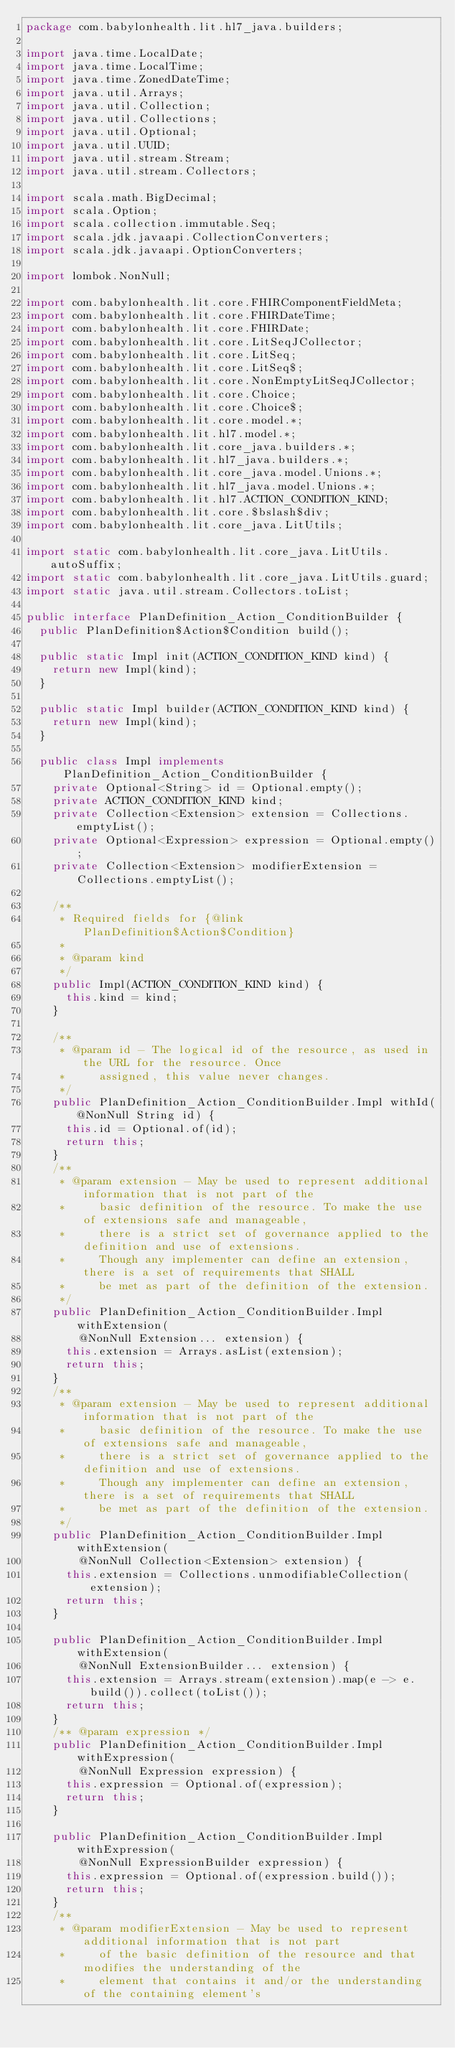<code> <loc_0><loc_0><loc_500><loc_500><_Java_>package com.babylonhealth.lit.hl7_java.builders;

import java.time.LocalDate;
import java.time.LocalTime;
import java.time.ZonedDateTime;
import java.util.Arrays;
import java.util.Collection;
import java.util.Collections;
import java.util.Optional;
import java.util.UUID;
import java.util.stream.Stream;
import java.util.stream.Collectors;

import scala.math.BigDecimal;
import scala.Option;
import scala.collection.immutable.Seq;
import scala.jdk.javaapi.CollectionConverters;
import scala.jdk.javaapi.OptionConverters;

import lombok.NonNull;

import com.babylonhealth.lit.core.FHIRComponentFieldMeta;
import com.babylonhealth.lit.core.FHIRDateTime;
import com.babylonhealth.lit.core.FHIRDate;
import com.babylonhealth.lit.core.LitSeqJCollector;
import com.babylonhealth.lit.core.LitSeq;
import com.babylonhealth.lit.core.LitSeq$;
import com.babylonhealth.lit.core.NonEmptyLitSeqJCollector;
import com.babylonhealth.lit.core.Choice;
import com.babylonhealth.lit.core.Choice$;
import com.babylonhealth.lit.core.model.*;
import com.babylonhealth.lit.hl7.model.*;
import com.babylonhealth.lit.core_java.builders.*;
import com.babylonhealth.lit.hl7_java.builders.*;
import com.babylonhealth.lit.core_java.model.Unions.*;
import com.babylonhealth.lit.hl7_java.model.Unions.*;
import com.babylonhealth.lit.hl7.ACTION_CONDITION_KIND;
import com.babylonhealth.lit.core.$bslash$div;
import com.babylonhealth.lit.core_java.LitUtils;

import static com.babylonhealth.lit.core_java.LitUtils.autoSuffix;
import static com.babylonhealth.lit.core_java.LitUtils.guard;
import static java.util.stream.Collectors.toList;

public interface PlanDefinition_Action_ConditionBuilder {
  public PlanDefinition$Action$Condition build();

  public static Impl init(ACTION_CONDITION_KIND kind) {
    return new Impl(kind);
  }

  public static Impl builder(ACTION_CONDITION_KIND kind) {
    return new Impl(kind);
  }

  public class Impl implements PlanDefinition_Action_ConditionBuilder {
    private Optional<String> id = Optional.empty();
    private ACTION_CONDITION_KIND kind;
    private Collection<Extension> extension = Collections.emptyList();
    private Optional<Expression> expression = Optional.empty();
    private Collection<Extension> modifierExtension = Collections.emptyList();

    /**
     * Required fields for {@link PlanDefinition$Action$Condition}
     *
     * @param kind
     */
    public Impl(ACTION_CONDITION_KIND kind) {
      this.kind = kind;
    }

    /**
     * @param id - The logical id of the resource, as used in the URL for the resource. Once
     *     assigned, this value never changes.
     */
    public PlanDefinition_Action_ConditionBuilder.Impl withId(@NonNull String id) {
      this.id = Optional.of(id);
      return this;
    }
    /**
     * @param extension - May be used to represent additional information that is not part of the
     *     basic definition of the resource. To make the use of extensions safe and manageable,
     *     there is a strict set of governance applied to the definition and use of extensions.
     *     Though any implementer can define an extension, there is a set of requirements that SHALL
     *     be met as part of the definition of the extension.
     */
    public PlanDefinition_Action_ConditionBuilder.Impl withExtension(
        @NonNull Extension... extension) {
      this.extension = Arrays.asList(extension);
      return this;
    }
    /**
     * @param extension - May be used to represent additional information that is not part of the
     *     basic definition of the resource. To make the use of extensions safe and manageable,
     *     there is a strict set of governance applied to the definition and use of extensions.
     *     Though any implementer can define an extension, there is a set of requirements that SHALL
     *     be met as part of the definition of the extension.
     */
    public PlanDefinition_Action_ConditionBuilder.Impl withExtension(
        @NonNull Collection<Extension> extension) {
      this.extension = Collections.unmodifiableCollection(extension);
      return this;
    }

    public PlanDefinition_Action_ConditionBuilder.Impl withExtension(
        @NonNull ExtensionBuilder... extension) {
      this.extension = Arrays.stream(extension).map(e -> e.build()).collect(toList());
      return this;
    }
    /** @param expression */
    public PlanDefinition_Action_ConditionBuilder.Impl withExpression(
        @NonNull Expression expression) {
      this.expression = Optional.of(expression);
      return this;
    }

    public PlanDefinition_Action_ConditionBuilder.Impl withExpression(
        @NonNull ExpressionBuilder expression) {
      this.expression = Optional.of(expression.build());
      return this;
    }
    /**
     * @param modifierExtension - May be used to represent additional information that is not part
     *     of the basic definition of the resource and that modifies the understanding of the
     *     element that contains it and/or the understanding of the containing element's</code> 